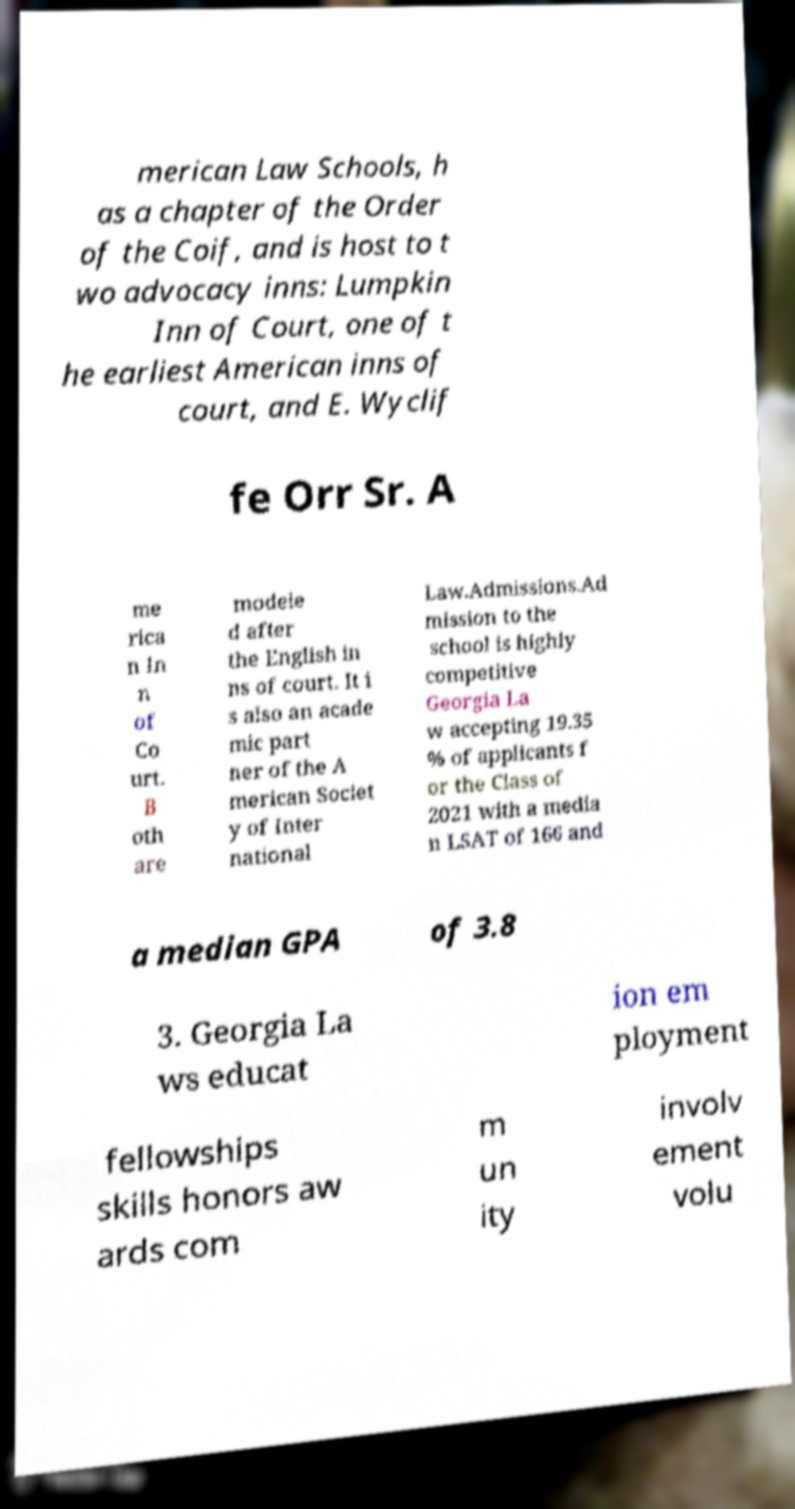Could you extract and type out the text from this image? merican Law Schools, h as a chapter of the Order of the Coif, and is host to t wo advocacy inns: Lumpkin Inn of Court, one of t he earliest American inns of court, and E. Wyclif fe Orr Sr. A me rica n In n of Co urt. B oth are modele d after the English in ns of court. It i s also an acade mic part ner of the A merican Societ y of Inter national Law.Admissions.Ad mission to the school is highly competitive Georgia La w accepting 19.35 % of applicants f or the Class of 2021 with a media n LSAT of 166 and a median GPA of 3.8 3. Georgia La ws educat ion em ployment fellowships skills honors aw ards com m un ity involv ement volu 